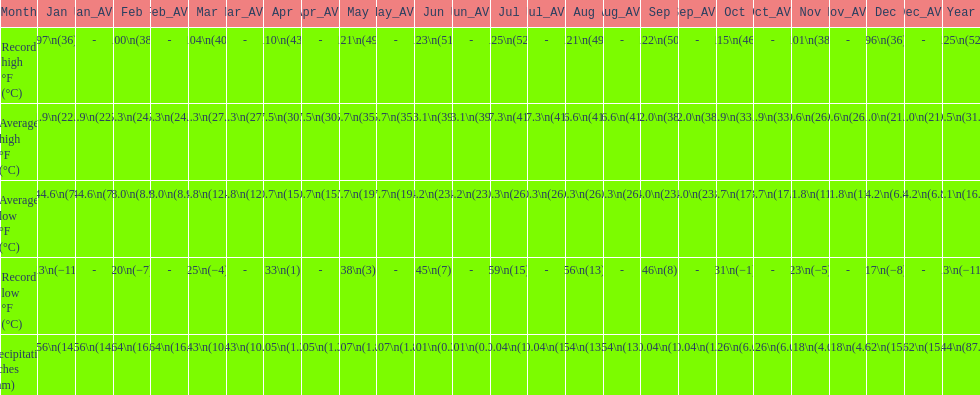How many months saw record lows below freezing? 7. 